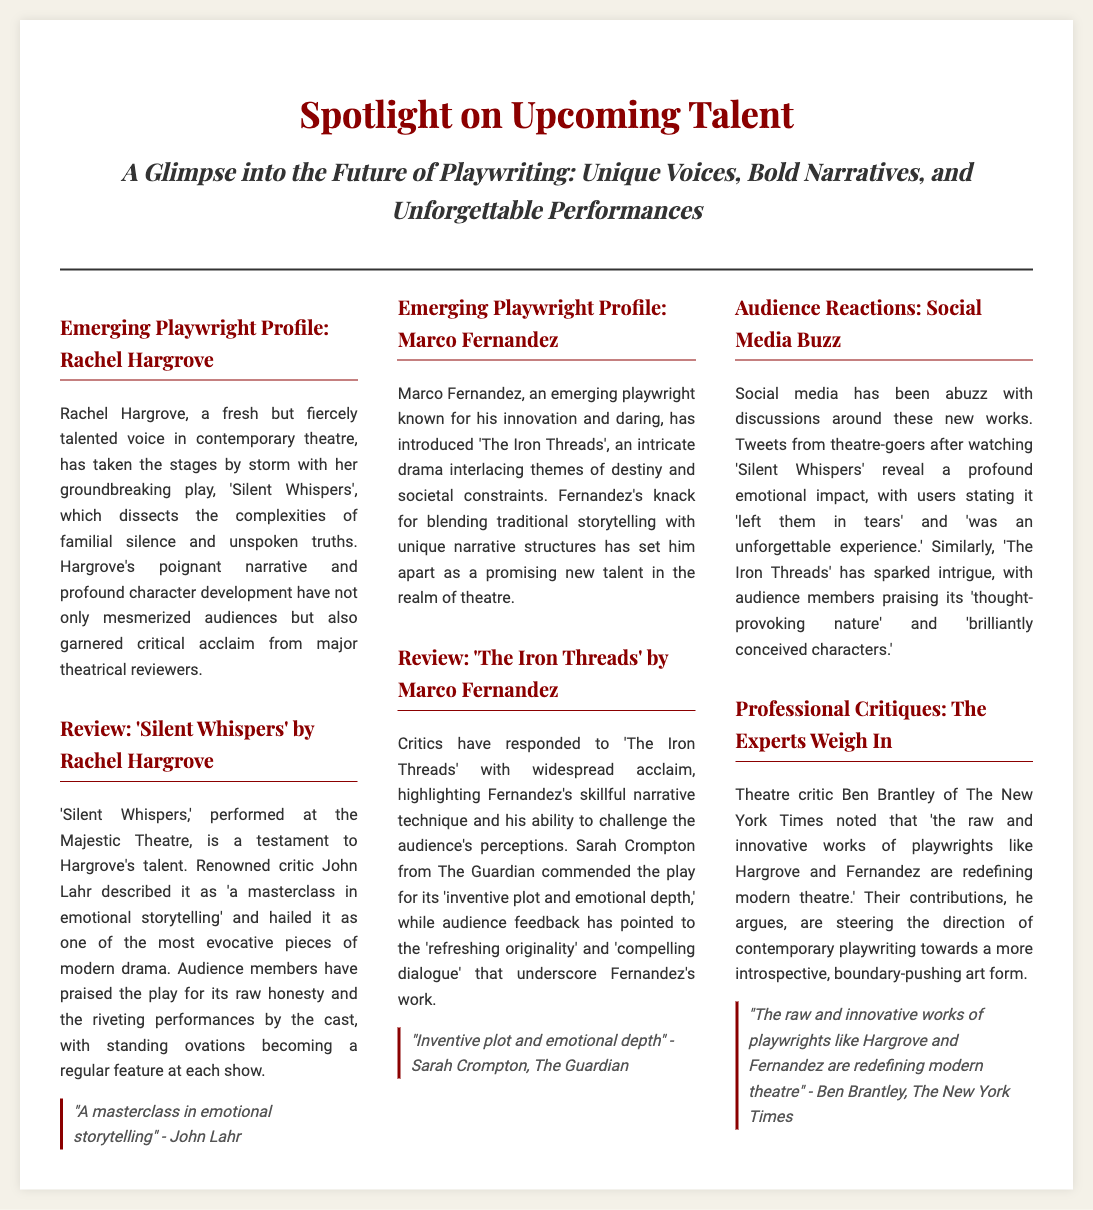What is the title of Rachel Hargrove's play? The title of Rachel Hargrove's play is mentioned as 'Silent Whispers'.
Answer: 'Silent Whispers' Who reviewed 'Silent Whispers'? The review of 'Silent Whispers' was done by renowned critic John Lahr.
Answer: John Lahr What themes does Marco Fernandez's play explore? The themes explored in Marco Fernandez's play 'The Iron Threads' include destiny and societal constraints.
Answer: Destiny and societal constraints Which theatre hosted 'The Iron Threads'? The document does not explicitly mention the theatre where 'The Iron Threads' was performed.
Answer: Not mentioned What does Sarah Crompton praise about 'The Iron Threads'? Sarah Crompton commends 'The Iron Threads' for its 'inventive plot and emotional depth'.
Answer: Inventive plot and emotional depth How do audience members describe their feelings after watching 'Silent Whispers'? Audience members express that 'it left them in tears' and 'was an unforgettable experience'.
Answer: Left them in tears What is the overall impression given by Ben Brantley regarding Hargrove and Fernandez? Ben Brantley notes that their works are 'redefining modern theatre'.
Answer: Redefining modern theatre What is the document identifying as its main focus? The main focus of the document is highlighted as a 'Spotlight on Upcoming Talent'.
Answer: Spotlight on Upcoming Talent 